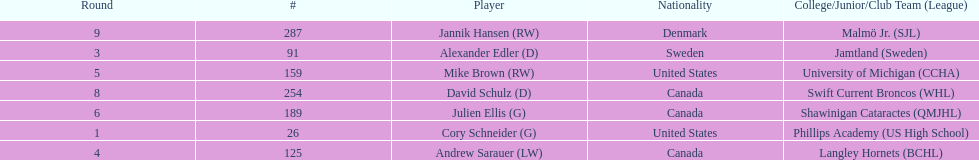How many goalies drafted? 2. 